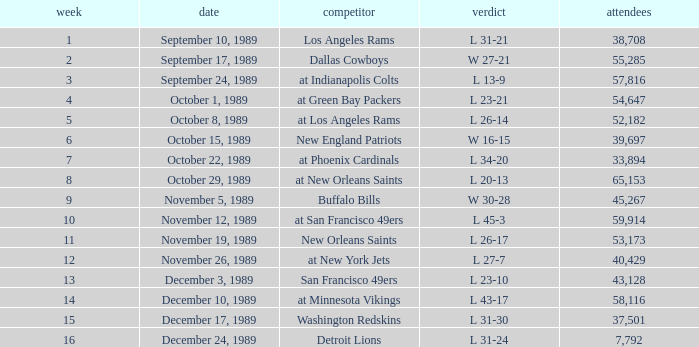The Detroit Lions were played against what week? 16.0. 